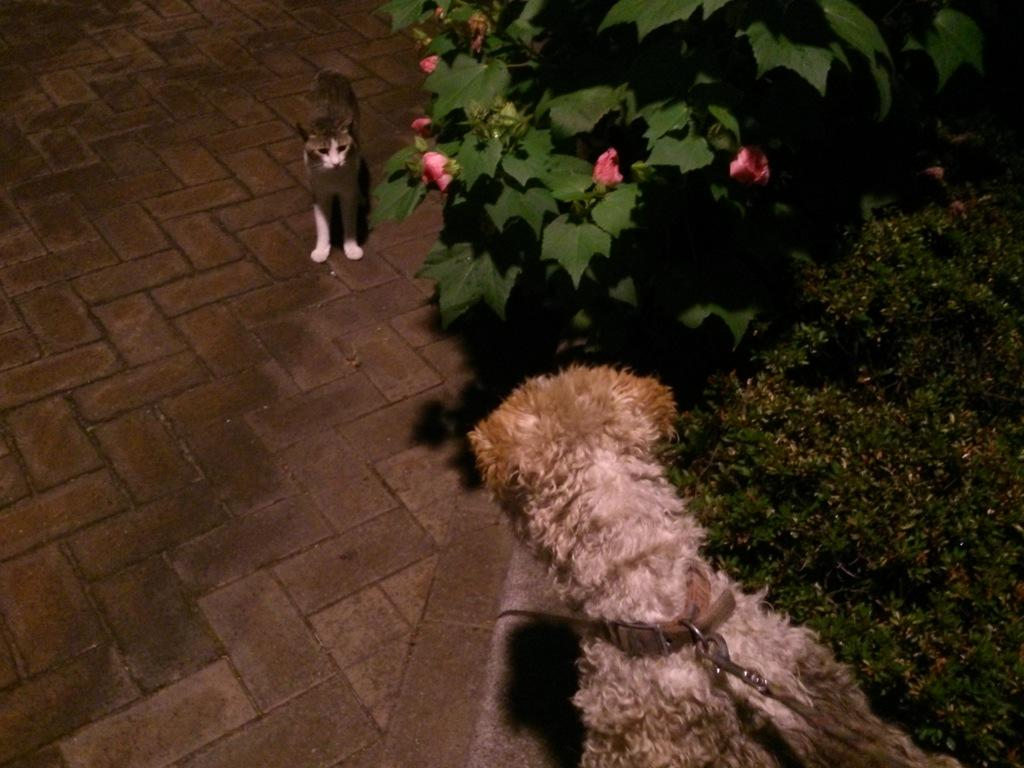What animals are present in the image? There is a cat and a dog in the image. What type of vegetation can be seen in the image? There are plants, flowers, and grass in the image. What type of lumber is being used to build the hall in the image? There is no hall or lumber present in the image; it features a cat, a dog, plants, flowers, and grass. 